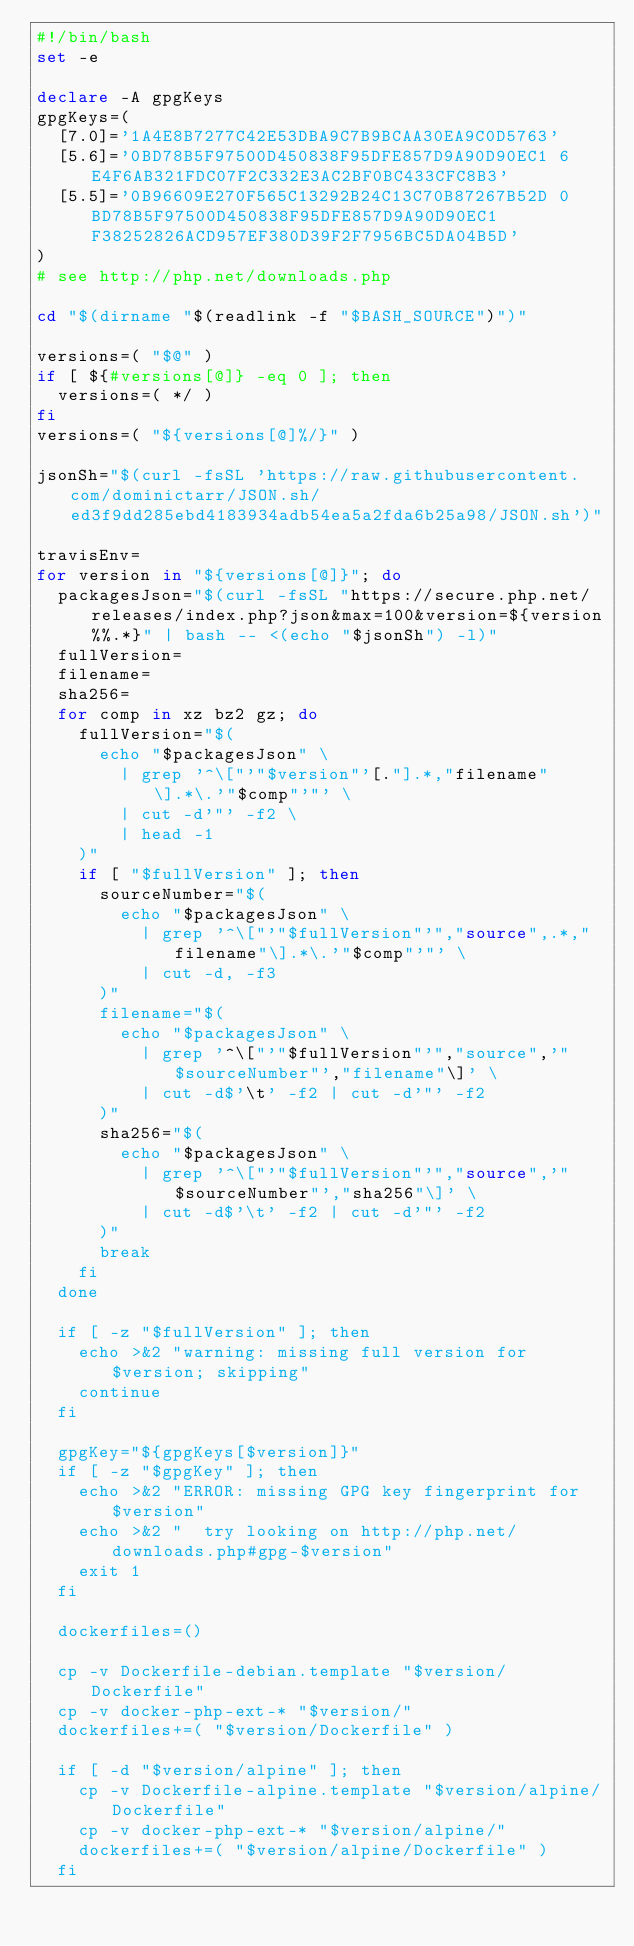Convert code to text. <code><loc_0><loc_0><loc_500><loc_500><_Bash_>#!/bin/bash
set -e

declare -A gpgKeys
gpgKeys=(
	[7.0]='1A4E8B7277C42E53DBA9C7B9BCAA30EA9C0D5763'
	[5.6]='0BD78B5F97500D450838F95DFE857D9A90D90EC1 6E4F6AB321FDC07F2C332E3AC2BF0BC433CFC8B3'
	[5.5]='0B96609E270F565C13292B24C13C70B87267B52D 0BD78B5F97500D450838F95DFE857D9A90D90EC1 F38252826ACD957EF380D39F2F7956BC5DA04B5D'
)
# see http://php.net/downloads.php

cd "$(dirname "$(readlink -f "$BASH_SOURCE")")"

versions=( "$@" )
if [ ${#versions[@]} -eq 0 ]; then
	versions=( */ )
fi
versions=( "${versions[@]%/}" )

jsonSh="$(curl -fsSL 'https://raw.githubusercontent.com/dominictarr/JSON.sh/ed3f9dd285ebd4183934adb54ea5a2fda6b25a98/JSON.sh')"

travisEnv=
for version in "${versions[@]}"; do
	packagesJson="$(curl -fsSL "https://secure.php.net/releases/index.php?json&max=100&version=${version%%.*}" | bash -- <(echo "$jsonSh") -l)"
	fullVersion=
	filename=
	sha256=
	for comp in xz bz2 gz; do
		fullVersion="$(
			echo "$packagesJson" \
				| grep '^\["'"$version"'[."].*,"filename"\].*\.'"$comp"'"' \
				| cut -d'"' -f2 \
				| head -1
		)"
		if [ "$fullVersion" ]; then
			sourceNumber="$(
				echo "$packagesJson" \
					| grep '^\["'"$fullVersion"'","source",.*,"filename"\].*\.'"$comp"'"' \
					| cut -d, -f3
			)"
			filename="$(
				echo "$packagesJson" \
					| grep '^\["'"$fullVersion"'","source",'"$sourceNumber"',"filename"\]' \
					| cut -d$'\t' -f2 | cut -d'"' -f2
			)"
			sha256="$(
				echo "$packagesJson" \
					| grep '^\["'"$fullVersion"'","source",'"$sourceNumber"',"sha256"\]' \
					| cut -d$'\t' -f2 | cut -d'"' -f2
			)"
			break
		fi
	done
	
	if [ -z "$fullVersion" ]; then
		echo >&2 "warning: missing full version for $version; skipping"
		continue
	fi
	
	gpgKey="${gpgKeys[$version]}"
	if [ -z "$gpgKey" ]; then
		echo >&2 "ERROR: missing GPG key fingerprint for $version"
		echo >&2 "  try looking on http://php.net/downloads.php#gpg-$version"
		exit 1
	fi
	
	dockerfiles=()
	
	cp -v Dockerfile-debian.template "$version/Dockerfile"
	cp -v docker-php-ext-* "$version/"
	dockerfiles+=( "$version/Dockerfile" )
	
	if [ -d "$version/alpine" ]; then
		cp -v Dockerfile-alpine.template "$version/alpine/Dockerfile"
		cp -v docker-php-ext-* "$version/alpine/"
		dockerfiles+=( "$version/alpine/Dockerfile" )
	fi
	</code> 